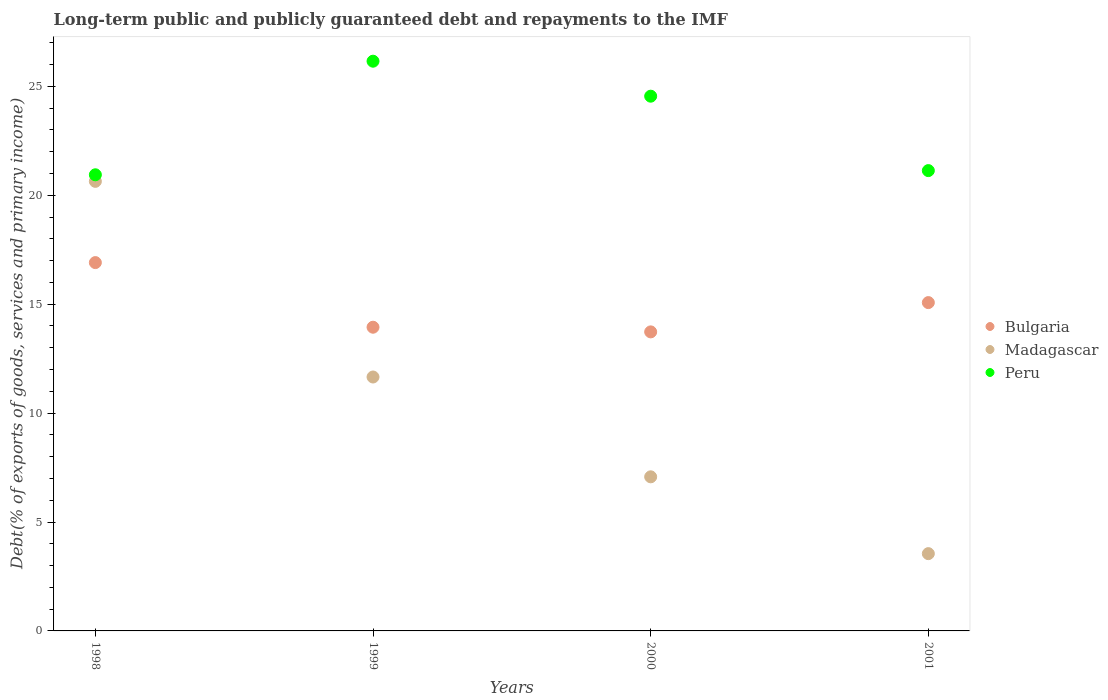How many different coloured dotlines are there?
Make the answer very short. 3. What is the debt and repayments in Madagascar in 1999?
Your response must be concise. 11.66. Across all years, what is the maximum debt and repayments in Madagascar?
Offer a terse response. 20.64. Across all years, what is the minimum debt and repayments in Bulgaria?
Your answer should be very brief. 13.73. In which year was the debt and repayments in Peru maximum?
Give a very brief answer. 1999. What is the total debt and repayments in Bulgaria in the graph?
Keep it short and to the point. 59.66. What is the difference between the debt and repayments in Madagascar in 1999 and that in 2000?
Offer a very short reply. 4.58. What is the difference between the debt and repayments in Madagascar in 1998 and the debt and repayments in Bulgaria in 2000?
Your answer should be compact. 6.91. What is the average debt and repayments in Madagascar per year?
Make the answer very short. 10.73. In the year 1999, what is the difference between the debt and repayments in Peru and debt and repayments in Bulgaria?
Ensure brevity in your answer.  12.21. In how many years, is the debt and repayments in Peru greater than 15 %?
Make the answer very short. 4. What is the ratio of the debt and repayments in Madagascar in 1998 to that in 2000?
Offer a very short reply. 2.92. Is the debt and repayments in Peru in 1998 less than that in 2000?
Keep it short and to the point. Yes. Is the difference between the debt and repayments in Peru in 1998 and 2000 greater than the difference between the debt and repayments in Bulgaria in 1998 and 2000?
Make the answer very short. No. What is the difference between the highest and the second highest debt and repayments in Madagascar?
Offer a terse response. 8.98. What is the difference between the highest and the lowest debt and repayments in Bulgaria?
Provide a short and direct response. 3.18. Is the sum of the debt and repayments in Peru in 1998 and 2000 greater than the maximum debt and repayments in Madagascar across all years?
Offer a very short reply. Yes. Is it the case that in every year, the sum of the debt and repayments in Peru and debt and repayments in Madagascar  is greater than the debt and repayments in Bulgaria?
Your response must be concise. Yes. Is the debt and repayments in Peru strictly greater than the debt and repayments in Bulgaria over the years?
Ensure brevity in your answer.  Yes. How many dotlines are there?
Offer a terse response. 3. What is the difference between two consecutive major ticks on the Y-axis?
Your response must be concise. 5. Does the graph contain grids?
Your answer should be compact. No. Where does the legend appear in the graph?
Your answer should be compact. Center right. How are the legend labels stacked?
Offer a terse response. Vertical. What is the title of the graph?
Your answer should be very brief. Long-term public and publicly guaranteed debt and repayments to the IMF. Does "Japan" appear as one of the legend labels in the graph?
Make the answer very short. No. What is the label or title of the X-axis?
Keep it short and to the point. Years. What is the label or title of the Y-axis?
Give a very brief answer. Debt(% of exports of goods, services and primary income). What is the Debt(% of exports of goods, services and primary income) in Bulgaria in 1998?
Ensure brevity in your answer.  16.91. What is the Debt(% of exports of goods, services and primary income) of Madagascar in 1998?
Your answer should be compact. 20.64. What is the Debt(% of exports of goods, services and primary income) of Peru in 1998?
Make the answer very short. 20.94. What is the Debt(% of exports of goods, services and primary income) in Bulgaria in 1999?
Give a very brief answer. 13.94. What is the Debt(% of exports of goods, services and primary income) of Madagascar in 1999?
Your answer should be compact. 11.66. What is the Debt(% of exports of goods, services and primary income) in Peru in 1999?
Offer a terse response. 26.16. What is the Debt(% of exports of goods, services and primary income) in Bulgaria in 2000?
Offer a terse response. 13.73. What is the Debt(% of exports of goods, services and primary income) in Madagascar in 2000?
Your response must be concise. 7.07. What is the Debt(% of exports of goods, services and primary income) in Peru in 2000?
Give a very brief answer. 24.55. What is the Debt(% of exports of goods, services and primary income) of Bulgaria in 2001?
Give a very brief answer. 15.07. What is the Debt(% of exports of goods, services and primary income) of Madagascar in 2001?
Offer a very short reply. 3.55. What is the Debt(% of exports of goods, services and primary income) in Peru in 2001?
Offer a terse response. 21.13. Across all years, what is the maximum Debt(% of exports of goods, services and primary income) of Bulgaria?
Give a very brief answer. 16.91. Across all years, what is the maximum Debt(% of exports of goods, services and primary income) of Madagascar?
Offer a very short reply. 20.64. Across all years, what is the maximum Debt(% of exports of goods, services and primary income) in Peru?
Make the answer very short. 26.16. Across all years, what is the minimum Debt(% of exports of goods, services and primary income) in Bulgaria?
Your answer should be very brief. 13.73. Across all years, what is the minimum Debt(% of exports of goods, services and primary income) in Madagascar?
Provide a short and direct response. 3.55. Across all years, what is the minimum Debt(% of exports of goods, services and primary income) of Peru?
Offer a very short reply. 20.94. What is the total Debt(% of exports of goods, services and primary income) in Bulgaria in the graph?
Make the answer very short. 59.66. What is the total Debt(% of exports of goods, services and primary income) of Madagascar in the graph?
Provide a short and direct response. 42.92. What is the total Debt(% of exports of goods, services and primary income) of Peru in the graph?
Provide a short and direct response. 92.78. What is the difference between the Debt(% of exports of goods, services and primary income) in Bulgaria in 1998 and that in 1999?
Give a very brief answer. 2.97. What is the difference between the Debt(% of exports of goods, services and primary income) of Madagascar in 1998 and that in 1999?
Offer a terse response. 8.98. What is the difference between the Debt(% of exports of goods, services and primary income) of Peru in 1998 and that in 1999?
Keep it short and to the point. -5.21. What is the difference between the Debt(% of exports of goods, services and primary income) in Bulgaria in 1998 and that in 2000?
Ensure brevity in your answer.  3.18. What is the difference between the Debt(% of exports of goods, services and primary income) of Madagascar in 1998 and that in 2000?
Offer a very short reply. 13.57. What is the difference between the Debt(% of exports of goods, services and primary income) in Peru in 1998 and that in 2000?
Offer a very short reply. -3.61. What is the difference between the Debt(% of exports of goods, services and primary income) of Bulgaria in 1998 and that in 2001?
Keep it short and to the point. 1.84. What is the difference between the Debt(% of exports of goods, services and primary income) of Madagascar in 1998 and that in 2001?
Give a very brief answer. 17.09. What is the difference between the Debt(% of exports of goods, services and primary income) in Peru in 1998 and that in 2001?
Your answer should be very brief. -0.19. What is the difference between the Debt(% of exports of goods, services and primary income) in Bulgaria in 1999 and that in 2000?
Your response must be concise. 0.21. What is the difference between the Debt(% of exports of goods, services and primary income) in Madagascar in 1999 and that in 2000?
Provide a succinct answer. 4.58. What is the difference between the Debt(% of exports of goods, services and primary income) in Peru in 1999 and that in 2000?
Offer a terse response. 1.61. What is the difference between the Debt(% of exports of goods, services and primary income) of Bulgaria in 1999 and that in 2001?
Make the answer very short. -1.13. What is the difference between the Debt(% of exports of goods, services and primary income) in Madagascar in 1999 and that in 2001?
Your answer should be very brief. 8.11. What is the difference between the Debt(% of exports of goods, services and primary income) in Peru in 1999 and that in 2001?
Offer a very short reply. 5.02. What is the difference between the Debt(% of exports of goods, services and primary income) in Bulgaria in 2000 and that in 2001?
Provide a succinct answer. -1.34. What is the difference between the Debt(% of exports of goods, services and primary income) in Madagascar in 2000 and that in 2001?
Your response must be concise. 3.53. What is the difference between the Debt(% of exports of goods, services and primary income) in Peru in 2000 and that in 2001?
Offer a very short reply. 3.42. What is the difference between the Debt(% of exports of goods, services and primary income) in Bulgaria in 1998 and the Debt(% of exports of goods, services and primary income) in Madagascar in 1999?
Your answer should be compact. 5.25. What is the difference between the Debt(% of exports of goods, services and primary income) in Bulgaria in 1998 and the Debt(% of exports of goods, services and primary income) in Peru in 1999?
Keep it short and to the point. -9.25. What is the difference between the Debt(% of exports of goods, services and primary income) of Madagascar in 1998 and the Debt(% of exports of goods, services and primary income) of Peru in 1999?
Offer a terse response. -5.52. What is the difference between the Debt(% of exports of goods, services and primary income) in Bulgaria in 1998 and the Debt(% of exports of goods, services and primary income) in Madagascar in 2000?
Your response must be concise. 9.84. What is the difference between the Debt(% of exports of goods, services and primary income) of Bulgaria in 1998 and the Debt(% of exports of goods, services and primary income) of Peru in 2000?
Provide a short and direct response. -7.64. What is the difference between the Debt(% of exports of goods, services and primary income) in Madagascar in 1998 and the Debt(% of exports of goods, services and primary income) in Peru in 2000?
Your answer should be very brief. -3.91. What is the difference between the Debt(% of exports of goods, services and primary income) in Bulgaria in 1998 and the Debt(% of exports of goods, services and primary income) in Madagascar in 2001?
Your answer should be very brief. 13.36. What is the difference between the Debt(% of exports of goods, services and primary income) in Bulgaria in 1998 and the Debt(% of exports of goods, services and primary income) in Peru in 2001?
Offer a very short reply. -4.22. What is the difference between the Debt(% of exports of goods, services and primary income) in Madagascar in 1998 and the Debt(% of exports of goods, services and primary income) in Peru in 2001?
Ensure brevity in your answer.  -0.49. What is the difference between the Debt(% of exports of goods, services and primary income) in Bulgaria in 1999 and the Debt(% of exports of goods, services and primary income) in Madagascar in 2000?
Keep it short and to the point. 6.87. What is the difference between the Debt(% of exports of goods, services and primary income) of Bulgaria in 1999 and the Debt(% of exports of goods, services and primary income) of Peru in 2000?
Provide a succinct answer. -10.61. What is the difference between the Debt(% of exports of goods, services and primary income) of Madagascar in 1999 and the Debt(% of exports of goods, services and primary income) of Peru in 2000?
Your answer should be compact. -12.89. What is the difference between the Debt(% of exports of goods, services and primary income) in Bulgaria in 1999 and the Debt(% of exports of goods, services and primary income) in Madagascar in 2001?
Give a very brief answer. 10.4. What is the difference between the Debt(% of exports of goods, services and primary income) of Bulgaria in 1999 and the Debt(% of exports of goods, services and primary income) of Peru in 2001?
Your answer should be very brief. -7.19. What is the difference between the Debt(% of exports of goods, services and primary income) in Madagascar in 1999 and the Debt(% of exports of goods, services and primary income) in Peru in 2001?
Make the answer very short. -9.48. What is the difference between the Debt(% of exports of goods, services and primary income) of Bulgaria in 2000 and the Debt(% of exports of goods, services and primary income) of Madagascar in 2001?
Offer a terse response. 10.18. What is the difference between the Debt(% of exports of goods, services and primary income) of Bulgaria in 2000 and the Debt(% of exports of goods, services and primary income) of Peru in 2001?
Offer a very short reply. -7.4. What is the difference between the Debt(% of exports of goods, services and primary income) of Madagascar in 2000 and the Debt(% of exports of goods, services and primary income) of Peru in 2001?
Provide a short and direct response. -14.06. What is the average Debt(% of exports of goods, services and primary income) in Bulgaria per year?
Give a very brief answer. 14.91. What is the average Debt(% of exports of goods, services and primary income) in Madagascar per year?
Your answer should be compact. 10.73. What is the average Debt(% of exports of goods, services and primary income) in Peru per year?
Your answer should be compact. 23.2. In the year 1998, what is the difference between the Debt(% of exports of goods, services and primary income) of Bulgaria and Debt(% of exports of goods, services and primary income) of Madagascar?
Your answer should be very brief. -3.73. In the year 1998, what is the difference between the Debt(% of exports of goods, services and primary income) of Bulgaria and Debt(% of exports of goods, services and primary income) of Peru?
Your answer should be very brief. -4.03. In the year 1998, what is the difference between the Debt(% of exports of goods, services and primary income) in Madagascar and Debt(% of exports of goods, services and primary income) in Peru?
Your response must be concise. -0.3. In the year 1999, what is the difference between the Debt(% of exports of goods, services and primary income) of Bulgaria and Debt(% of exports of goods, services and primary income) of Madagascar?
Offer a terse response. 2.29. In the year 1999, what is the difference between the Debt(% of exports of goods, services and primary income) in Bulgaria and Debt(% of exports of goods, services and primary income) in Peru?
Your answer should be very brief. -12.21. In the year 1999, what is the difference between the Debt(% of exports of goods, services and primary income) of Madagascar and Debt(% of exports of goods, services and primary income) of Peru?
Provide a short and direct response. -14.5. In the year 2000, what is the difference between the Debt(% of exports of goods, services and primary income) of Bulgaria and Debt(% of exports of goods, services and primary income) of Madagascar?
Offer a very short reply. 6.65. In the year 2000, what is the difference between the Debt(% of exports of goods, services and primary income) in Bulgaria and Debt(% of exports of goods, services and primary income) in Peru?
Provide a short and direct response. -10.82. In the year 2000, what is the difference between the Debt(% of exports of goods, services and primary income) of Madagascar and Debt(% of exports of goods, services and primary income) of Peru?
Your answer should be very brief. -17.48. In the year 2001, what is the difference between the Debt(% of exports of goods, services and primary income) in Bulgaria and Debt(% of exports of goods, services and primary income) in Madagascar?
Ensure brevity in your answer.  11.53. In the year 2001, what is the difference between the Debt(% of exports of goods, services and primary income) in Bulgaria and Debt(% of exports of goods, services and primary income) in Peru?
Give a very brief answer. -6.06. In the year 2001, what is the difference between the Debt(% of exports of goods, services and primary income) of Madagascar and Debt(% of exports of goods, services and primary income) of Peru?
Keep it short and to the point. -17.59. What is the ratio of the Debt(% of exports of goods, services and primary income) of Bulgaria in 1998 to that in 1999?
Give a very brief answer. 1.21. What is the ratio of the Debt(% of exports of goods, services and primary income) in Madagascar in 1998 to that in 1999?
Give a very brief answer. 1.77. What is the ratio of the Debt(% of exports of goods, services and primary income) of Peru in 1998 to that in 1999?
Provide a short and direct response. 0.8. What is the ratio of the Debt(% of exports of goods, services and primary income) in Bulgaria in 1998 to that in 2000?
Provide a succinct answer. 1.23. What is the ratio of the Debt(% of exports of goods, services and primary income) in Madagascar in 1998 to that in 2000?
Give a very brief answer. 2.92. What is the ratio of the Debt(% of exports of goods, services and primary income) in Peru in 1998 to that in 2000?
Your response must be concise. 0.85. What is the ratio of the Debt(% of exports of goods, services and primary income) in Bulgaria in 1998 to that in 2001?
Give a very brief answer. 1.12. What is the ratio of the Debt(% of exports of goods, services and primary income) of Madagascar in 1998 to that in 2001?
Ensure brevity in your answer.  5.82. What is the ratio of the Debt(% of exports of goods, services and primary income) of Peru in 1998 to that in 2001?
Your answer should be compact. 0.99. What is the ratio of the Debt(% of exports of goods, services and primary income) of Bulgaria in 1999 to that in 2000?
Your response must be concise. 1.02. What is the ratio of the Debt(% of exports of goods, services and primary income) of Madagascar in 1999 to that in 2000?
Provide a succinct answer. 1.65. What is the ratio of the Debt(% of exports of goods, services and primary income) of Peru in 1999 to that in 2000?
Your answer should be compact. 1.07. What is the ratio of the Debt(% of exports of goods, services and primary income) in Bulgaria in 1999 to that in 2001?
Provide a succinct answer. 0.93. What is the ratio of the Debt(% of exports of goods, services and primary income) of Madagascar in 1999 to that in 2001?
Give a very brief answer. 3.29. What is the ratio of the Debt(% of exports of goods, services and primary income) of Peru in 1999 to that in 2001?
Offer a terse response. 1.24. What is the ratio of the Debt(% of exports of goods, services and primary income) in Bulgaria in 2000 to that in 2001?
Your answer should be very brief. 0.91. What is the ratio of the Debt(% of exports of goods, services and primary income) of Madagascar in 2000 to that in 2001?
Your answer should be compact. 1.99. What is the ratio of the Debt(% of exports of goods, services and primary income) in Peru in 2000 to that in 2001?
Offer a very short reply. 1.16. What is the difference between the highest and the second highest Debt(% of exports of goods, services and primary income) of Bulgaria?
Offer a terse response. 1.84. What is the difference between the highest and the second highest Debt(% of exports of goods, services and primary income) in Madagascar?
Offer a very short reply. 8.98. What is the difference between the highest and the second highest Debt(% of exports of goods, services and primary income) of Peru?
Your response must be concise. 1.61. What is the difference between the highest and the lowest Debt(% of exports of goods, services and primary income) in Bulgaria?
Your response must be concise. 3.18. What is the difference between the highest and the lowest Debt(% of exports of goods, services and primary income) of Madagascar?
Ensure brevity in your answer.  17.09. What is the difference between the highest and the lowest Debt(% of exports of goods, services and primary income) in Peru?
Provide a succinct answer. 5.21. 